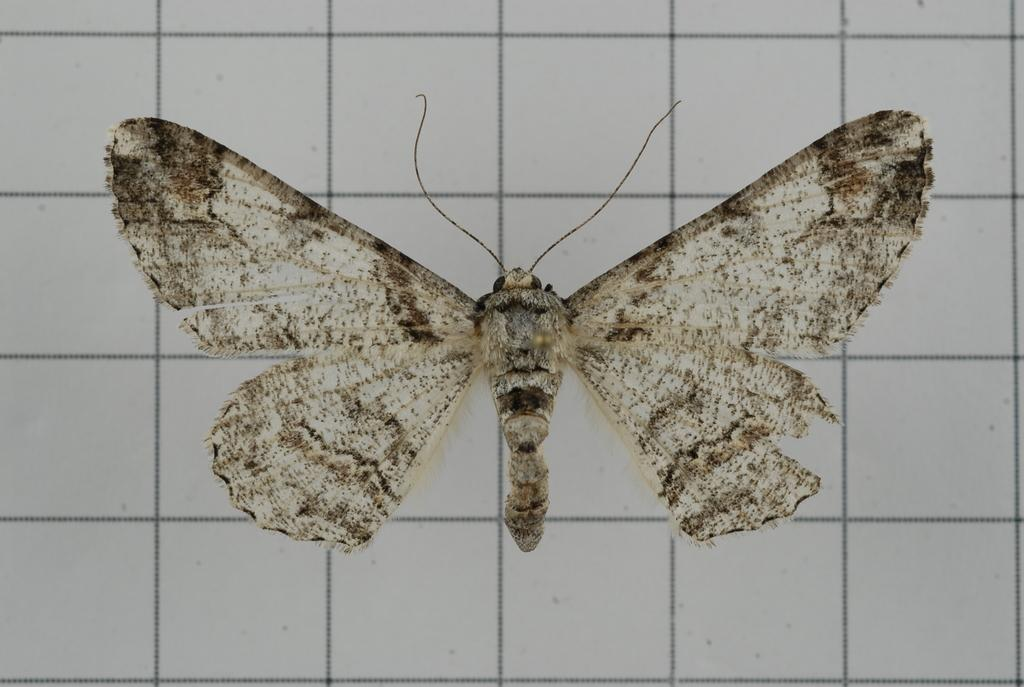What is the main subject of the image? There is a butterfly in the image. Where is the butterfly located in the image? The butterfly is on a graph. What time of day is the butterfly performing an action in the image? The image does not depict a specific time of day or an action being performed by the butterfly. 